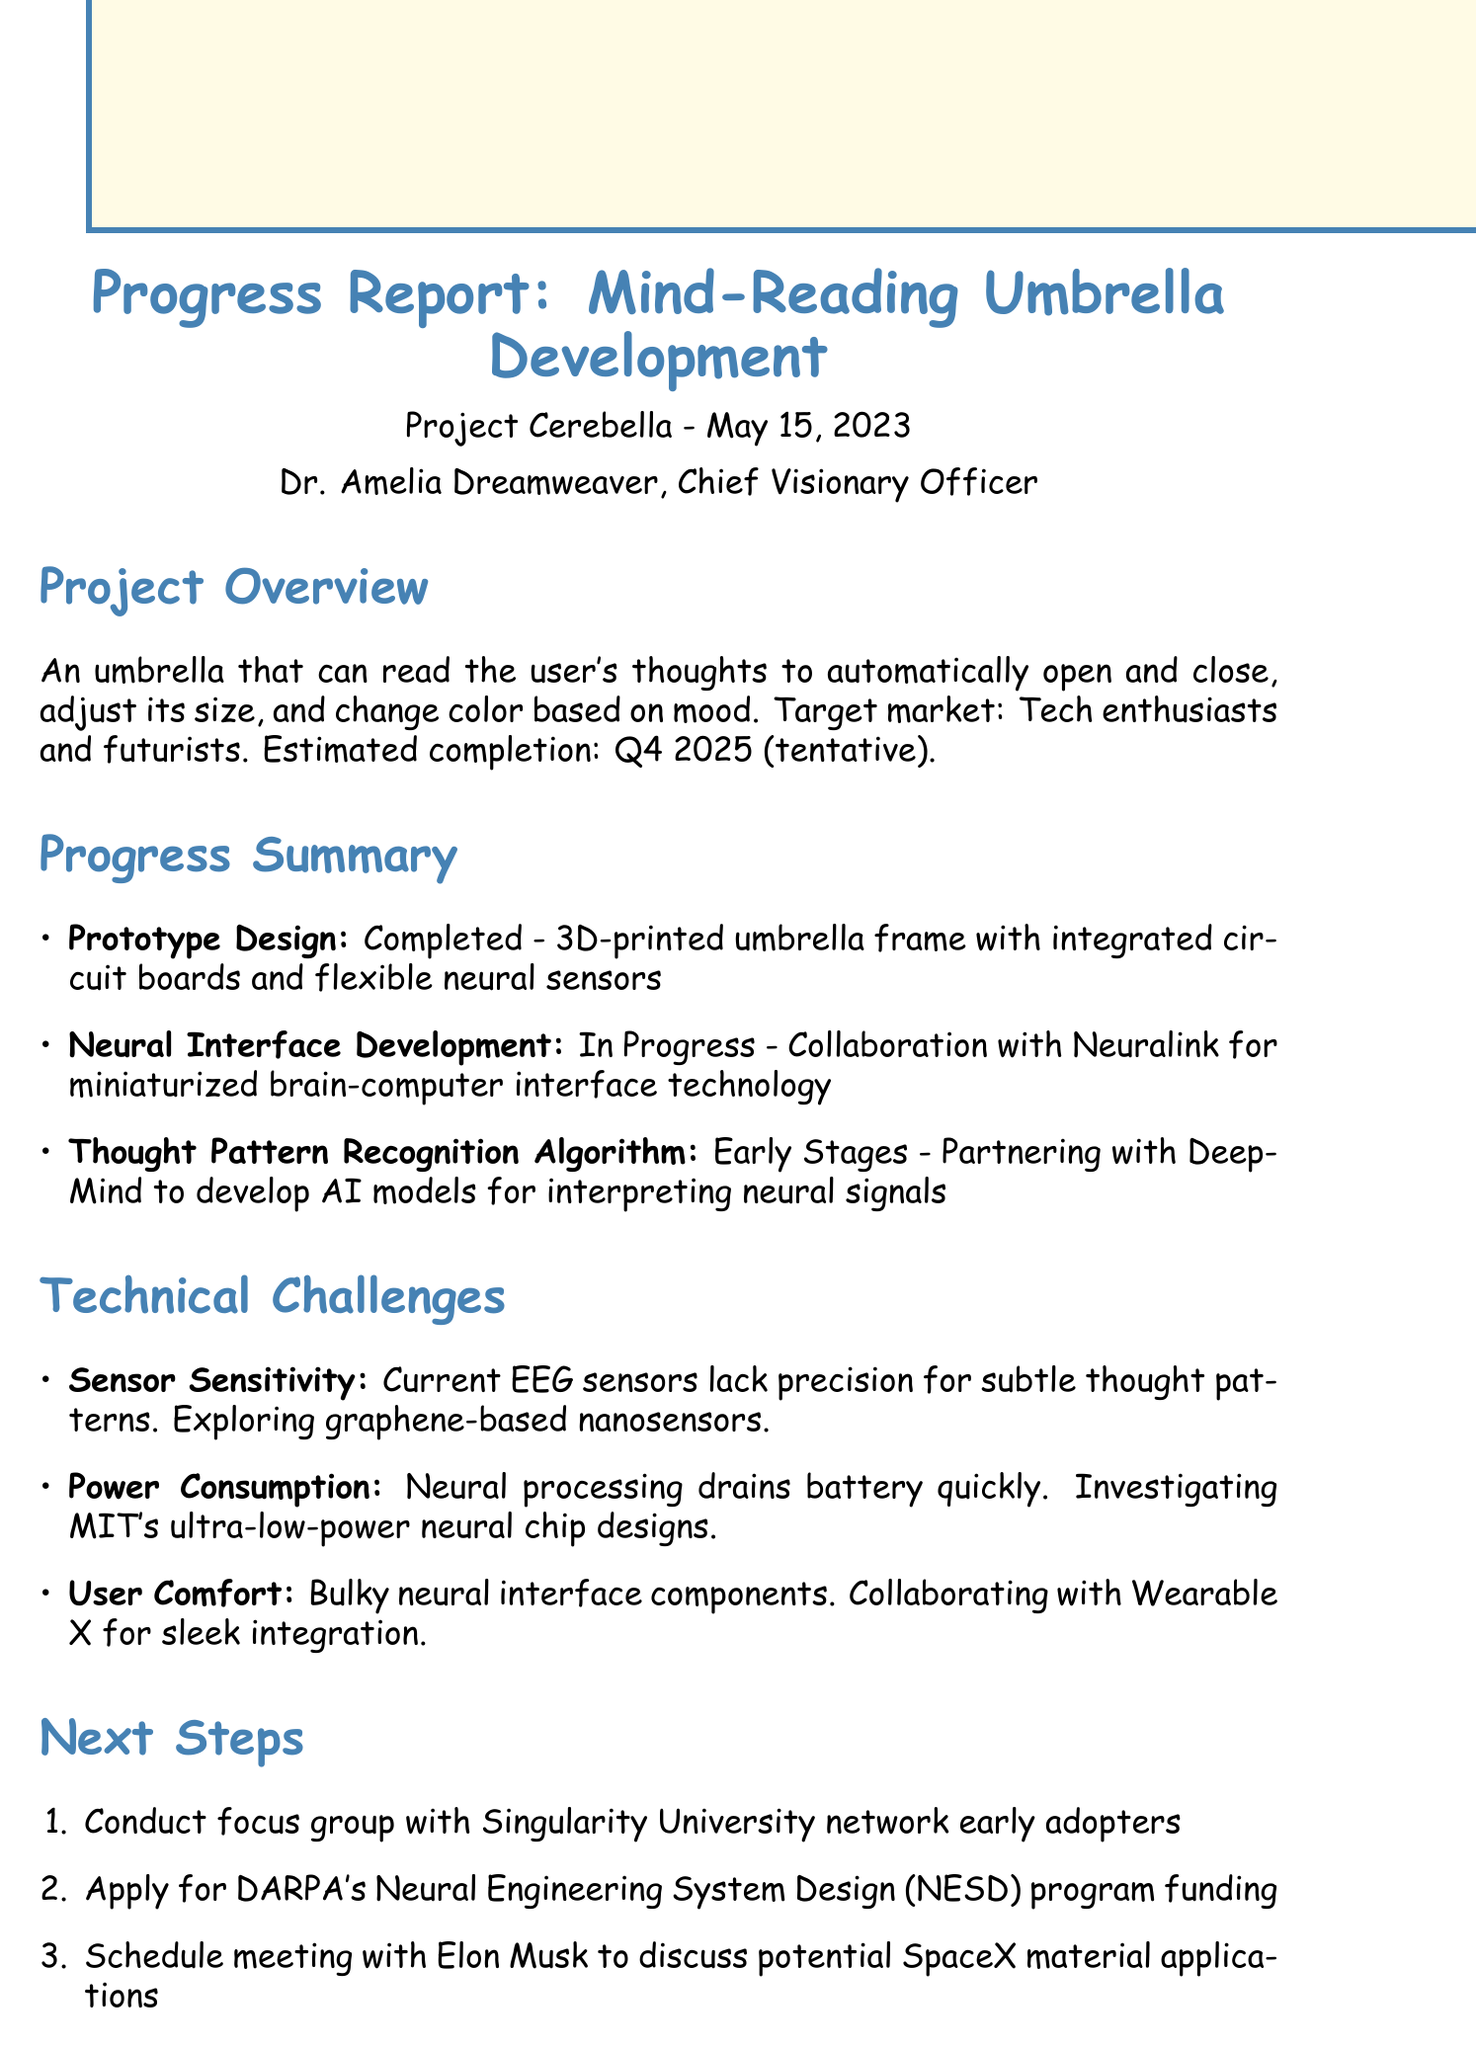What is the project code? The project code is mentioned in the document as Project Cerebella.
Answer: Project Cerebella Who is the lead neurotechnologist? The document lists Dr. Sophia Chen as the Lead Neurotechnologist.
Answer: Dr. Sophia Chen What is the estimated completion date? The estimated completion date is specified in the overview as Q4 2025 (tentative).
Answer: Q4 2025 (tentative) What is the remaining budget? The remaining budget is calculated by subtracting the amount spent from the total budget, which is $1.75 million.
Answer: $1.75 million What technical challenge involves comfort? The technical challenge related to comfort is described as User Comfort.
Answer: User Comfort What algorithm recognition accuracy improvement is mentioned? The document states that the thought pattern recognition accuracy improved from 45% to 62%.
Answer: 45% to 62% What is the collaboration with Neuralink about? Neuralink is collaborating on the development of miniaturized brain-computer interface technology.
Answer: Miniaturized brain-computer interface technology What ethical risk does the project face? The document outlines Ethical Concerns as a significant risk.
Answer: Ethical Concerns How much has been spent so far? The spending so far is mentioned as $750,000.
Answer: $750,000 